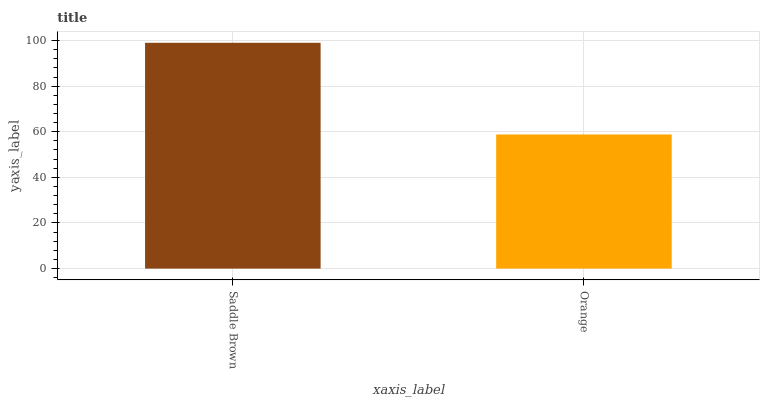Is Orange the minimum?
Answer yes or no. Yes. Is Saddle Brown the maximum?
Answer yes or no. Yes. Is Orange the maximum?
Answer yes or no. No. Is Saddle Brown greater than Orange?
Answer yes or no. Yes. Is Orange less than Saddle Brown?
Answer yes or no. Yes. Is Orange greater than Saddle Brown?
Answer yes or no. No. Is Saddle Brown less than Orange?
Answer yes or no. No. Is Saddle Brown the high median?
Answer yes or no. Yes. Is Orange the low median?
Answer yes or no. Yes. Is Orange the high median?
Answer yes or no. No. Is Saddle Brown the low median?
Answer yes or no. No. 